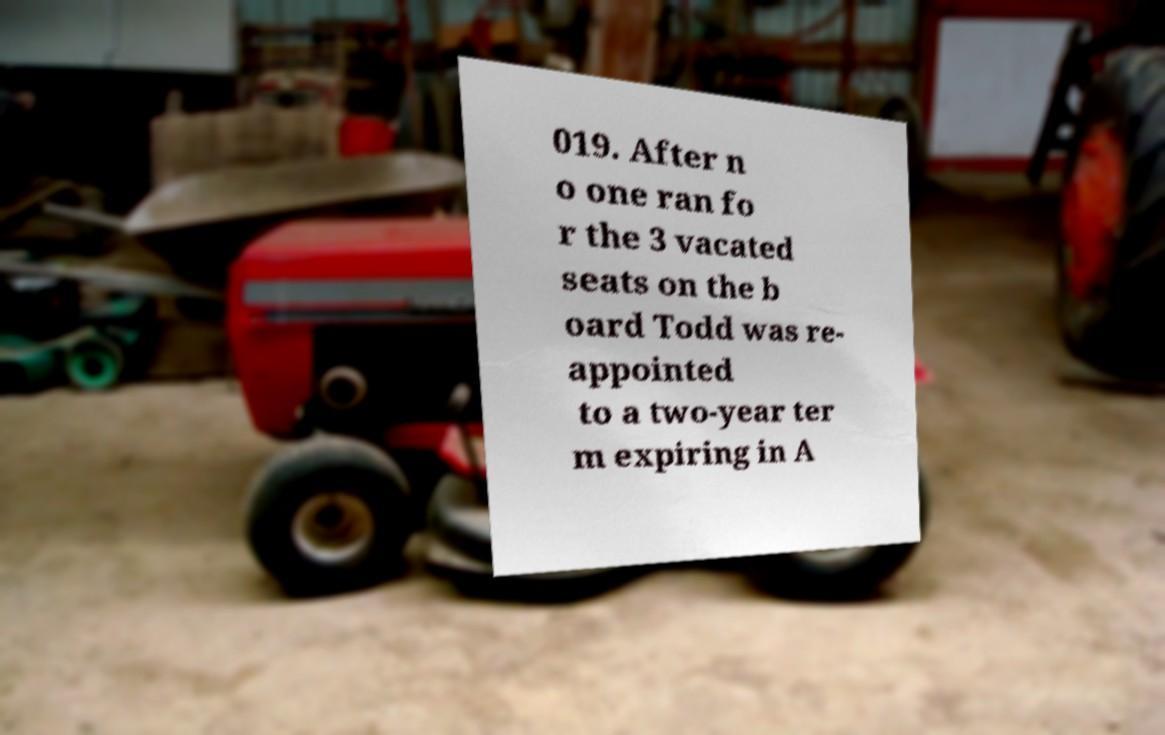What messages or text are displayed in this image? I need them in a readable, typed format. 019. After n o one ran fo r the 3 vacated seats on the b oard Todd was re- appointed to a two-year ter m expiring in A 